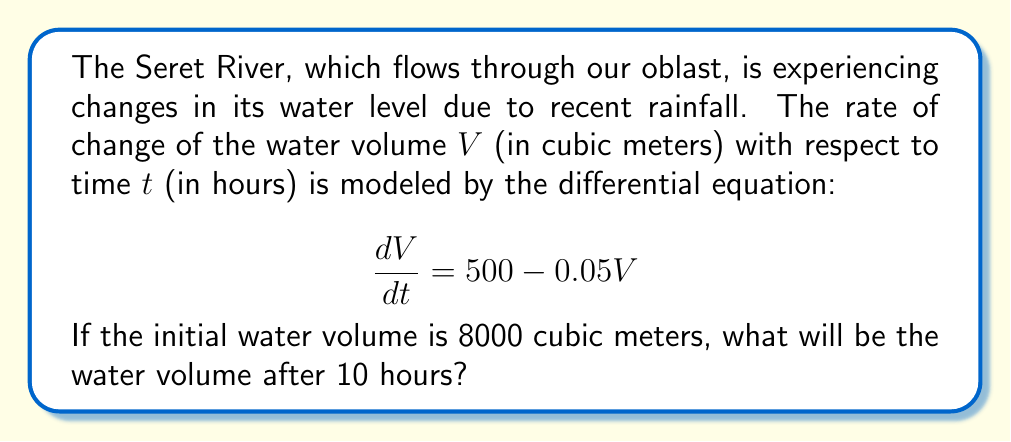Show me your answer to this math problem. Let's solve this problem step by step:

1) We have a first-order linear differential equation:

   $$\frac{dV}{dt} = 500 - 0.05V$$

2) This is in the form $\frac{dV}{dt} + PV = Q$, where $P = 0.05$ and $Q = 500$.

3) The general solution for this type of equation is:

   $$V = e^{-\int P dt} (\int Q e^{\int P dt} dt + C)$$

4) Let's solve the integrals:
   
   $\int P dt = \int 0.05 dt = 0.05t$
   
   $e^{\int P dt} = e^{0.05t}$

5) Now, let's substitute these into the general solution:

   $$V = e^{-0.05t} (\int 500 e^{0.05t} dt + C)$$

6) Solving the integral:

   $$V = e^{-0.05t} (\frac{500}{0.05} e^{0.05t} + C) = 10000 + Ce^{-0.05t}$$

7) We're given the initial condition: $V(0) = 8000$. Let's use this to find $C$:

   $8000 = 10000 + C$
   $C = -2000$

8) So, our particular solution is:

   $$V = 10000 - 2000e^{-0.05t}$$

9) To find the volume after 10 hours, we substitute $t = 10$:

   $$V(10) = 10000 - 2000e^{-0.05(10)} = 10000 - 2000e^{-0.5}$$

10) Calculating this:

    $$V(10) = 10000 - 2000(0.6065) = 10000 - 1213 = 8787$$

Therefore, after 10 hours, the water volume will be approximately 8787 cubic meters.
Answer: $8787$ cubic meters 